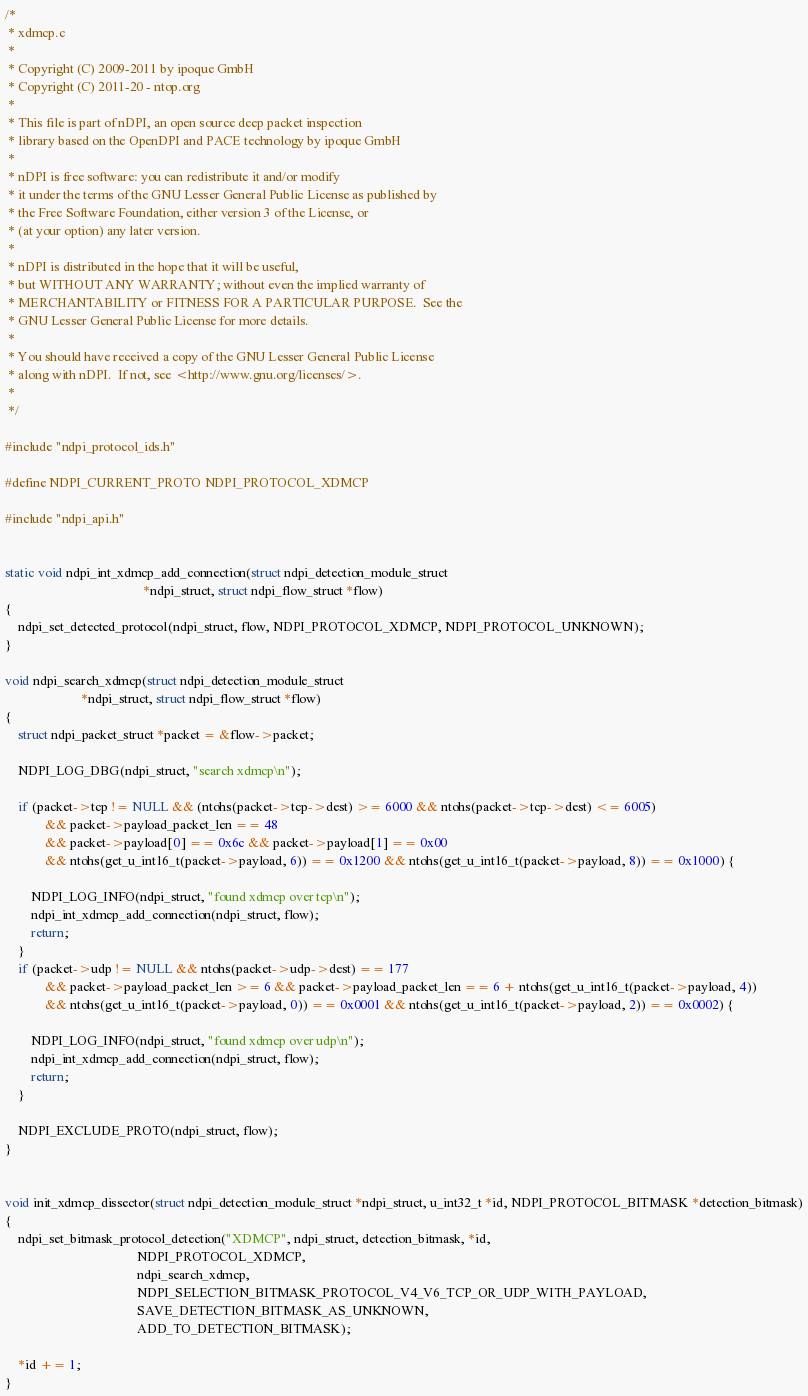Convert code to text. <code><loc_0><loc_0><loc_500><loc_500><_C_>/*
 * xdmcp.c
 *
 * Copyright (C) 2009-2011 by ipoque GmbH
 * Copyright (C) 2011-20 - ntop.org
 *
 * This file is part of nDPI, an open source deep packet inspection
 * library based on the OpenDPI and PACE technology by ipoque GmbH
 *
 * nDPI is free software: you can redistribute it and/or modify
 * it under the terms of the GNU Lesser General Public License as published by
 * the Free Software Foundation, either version 3 of the License, or
 * (at your option) any later version.
 *
 * nDPI is distributed in the hope that it will be useful,
 * but WITHOUT ANY WARRANTY; without even the implied warranty of
 * MERCHANTABILITY or FITNESS FOR A PARTICULAR PURPOSE.  See the
 * GNU Lesser General Public License for more details.
 *
 * You should have received a copy of the GNU Lesser General Public License
 * along with nDPI.  If not, see <http://www.gnu.org/licenses/>.
 *
 */

#include "ndpi_protocol_ids.h"

#define NDPI_CURRENT_PROTO NDPI_PROTOCOL_XDMCP

#include "ndpi_api.h"


static void ndpi_int_xdmcp_add_connection(struct ndpi_detection_module_struct
                                          *ndpi_struct, struct ndpi_flow_struct *flow)
{
    ndpi_set_detected_protocol(ndpi_struct, flow, NDPI_PROTOCOL_XDMCP, NDPI_PROTOCOL_UNKNOWN);
}

void ndpi_search_xdmcp(struct ndpi_detection_module_struct
                       *ndpi_struct, struct ndpi_flow_struct *flow)
{
    struct ndpi_packet_struct *packet = &flow->packet;

    NDPI_LOG_DBG(ndpi_struct, "search xdmcp\n");

    if (packet->tcp != NULL && (ntohs(packet->tcp->dest) >= 6000 && ntohs(packet->tcp->dest) <= 6005)
            && packet->payload_packet_len == 48
            && packet->payload[0] == 0x6c && packet->payload[1] == 0x00
            && ntohs(get_u_int16_t(packet->payload, 6)) == 0x1200 && ntohs(get_u_int16_t(packet->payload, 8)) == 0x1000) {

        NDPI_LOG_INFO(ndpi_struct, "found xdmcp over tcp\n");
        ndpi_int_xdmcp_add_connection(ndpi_struct, flow);
        return;
    }
    if (packet->udp != NULL && ntohs(packet->udp->dest) == 177
            && packet->payload_packet_len >= 6 && packet->payload_packet_len == 6 + ntohs(get_u_int16_t(packet->payload, 4))
            && ntohs(get_u_int16_t(packet->payload, 0)) == 0x0001 && ntohs(get_u_int16_t(packet->payload, 2)) == 0x0002) {

        NDPI_LOG_INFO(ndpi_struct, "found xdmcp over udp\n");
        ndpi_int_xdmcp_add_connection(ndpi_struct, flow);
        return;
    }

    NDPI_EXCLUDE_PROTO(ndpi_struct, flow);
}


void init_xdmcp_dissector(struct ndpi_detection_module_struct *ndpi_struct, u_int32_t *id, NDPI_PROTOCOL_BITMASK *detection_bitmask)
{
    ndpi_set_bitmask_protocol_detection("XDMCP", ndpi_struct, detection_bitmask, *id,
                                        NDPI_PROTOCOL_XDMCP,
                                        ndpi_search_xdmcp,
                                        NDPI_SELECTION_BITMASK_PROTOCOL_V4_V6_TCP_OR_UDP_WITH_PAYLOAD,
                                        SAVE_DETECTION_BITMASK_AS_UNKNOWN,
                                        ADD_TO_DETECTION_BITMASK);

    *id += 1;
}
</code> 